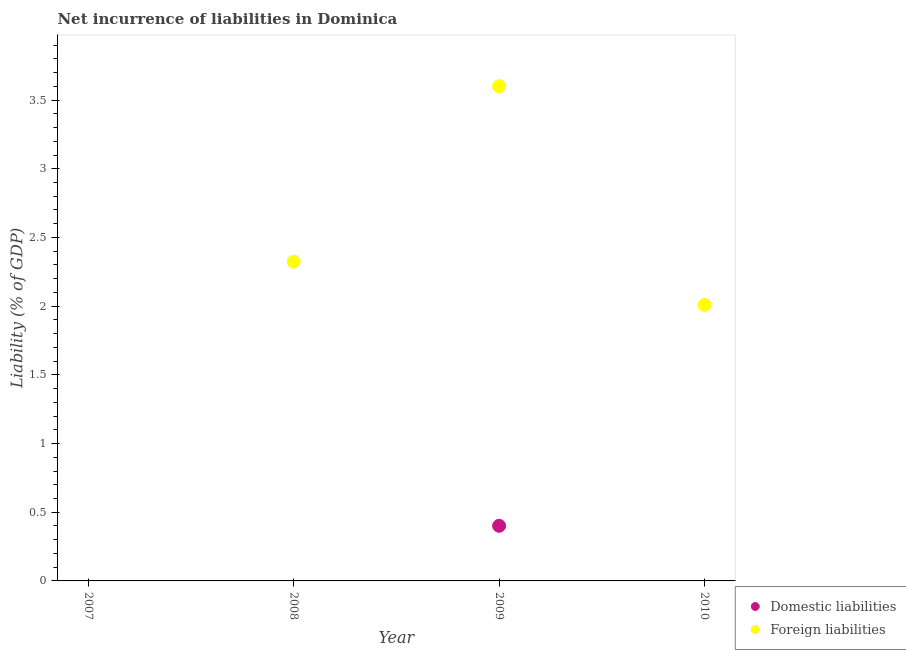How many different coloured dotlines are there?
Your response must be concise. 2. Is the number of dotlines equal to the number of legend labels?
Offer a very short reply. No. What is the incurrence of foreign liabilities in 2010?
Offer a very short reply. 2.01. Across all years, what is the maximum incurrence of foreign liabilities?
Keep it short and to the point. 3.6. Across all years, what is the minimum incurrence of domestic liabilities?
Keep it short and to the point. 0. What is the total incurrence of domestic liabilities in the graph?
Give a very brief answer. 0.4. What is the difference between the incurrence of foreign liabilities in 2008 and that in 2010?
Provide a succinct answer. 0.32. What is the difference between the incurrence of domestic liabilities in 2010 and the incurrence of foreign liabilities in 2008?
Offer a very short reply. -2.32. What is the average incurrence of foreign liabilities per year?
Your answer should be very brief. 1.98. In the year 2009, what is the difference between the incurrence of foreign liabilities and incurrence of domestic liabilities?
Your answer should be compact. 3.2. In how many years, is the incurrence of domestic liabilities greater than 3.1 %?
Offer a very short reply. 0. What is the ratio of the incurrence of foreign liabilities in 2008 to that in 2009?
Offer a very short reply. 0.65. What is the difference between the highest and the second highest incurrence of foreign liabilities?
Your response must be concise. 1.28. What is the difference between the highest and the lowest incurrence of domestic liabilities?
Give a very brief answer. 0.4. How many years are there in the graph?
Your answer should be very brief. 4. What is the difference between two consecutive major ticks on the Y-axis?
Your response must be concise. 0.5. Does the graph contain grids?
Keep it short and to the point. No. Where does the legend appear in the graph?
Make the answer very short. Bottom right. How many legend labels are there?
Provide a short and direct response. 2. What is the title of the graph?
Give a very brief answer. Net incurrence of liabilities in Dominica. Does "Urban" appear as one of the legend labels in the graph?
Ensure brevity in your answer.  No. What is the label or title of the Y-axis?
Make the answer very short. Liability (% of GDP). What is the Liability (% of GDP) in Foreign liabilities in 2008?
Make the answer very short. 2.32. What is the Liability (% of GDP) in Domestic liabilities in 2009?
Keep it short and to the point. 0.4. What is the Liability (% of GDP) in Foreign liabilities in 2009?
Your answer should be compact. 3.6. What is the Liability (% of GDP) of Domestic liabilities in 2010?
Make the answer very short. 0. What is the Liability (% of GDP) in Foreign liabilities in 2010?
Your answer should be very brief. 2.01. Across all years, what is the maximum Liability (% of GDP) of Domestic liabilities?
Keep it short and to the point. 0.4. Across all years, what is the maximum Liability (% of GDP) in Foreign liabilities?
Give a very brief answer. 3.6. What is the total Liability (% of GDP) in Domestic liabilities in the graph?
Provide a short and direct response. 0.4. What is the total Liability (% of GDP) of Foreign liabilities in the graph?
Your answer should be compact. 7.93. What is the difference between the Liability (% of GDP) of Foreign liabilities in 2008 and that in 2009?
Your answer should be very brief. -1.28. What is the difference between the Liability (% of GDP) of Foreign liabilities in 2008 and that in 2010?
Keep it short and to the point. 0.32. What is the difference between the Liability (% of GDP) in Foreign liabilities in 2009 and that in 2010?
Ensure brevity in your answer.  1.59. What is the difference between the Liability (% of GDP) in Domestic liabilities in 2009 and the Liability (% of GDP) in Foreign liabilities in 2010?
Ensure brevity in your answer.  -1.61. What is the average Liability (% of GDP) of Domestic liabilities per year?
Your answer should be very brief. 0.1. What is the average Liability (% of GDP) of Foreign liabilities per year?
Offer a terse response. 1.98. In the year 2009, what is the difference between the Liability (% of GDP) of Domestic liabilities and Liability (% of GDP) of Foreign liabilities?
Ensure brevity in your answer.  -3.2. What is the ratio of the Liability (% of GDP) in Foreign liabilities in 2008 to that in 2009?
Your answer should be very brief. 0.65. What is the ratio of the Liability (% of GDP) of Foreign liabilities in 2008 to that in 2010?
Provide a succinct answer. 1.16. What is the ratio of the Liability (% of GDP) of Foreign liabilities in 2009 to that in 2010?
Keep it short and to the point. 1.79. What is the difference between the highest and the second highest Liability (% of GDP) in Foreign liabilities?
Ensure brevity in your answer.  1.28. What is the difference between the highest and the lowest Liability (% of GDP) in Domestic liabilities?
Offer a terse response. 0.4. What is the difference between the highest and the lowest Liability (% of GDP) of Foreign liabilities?
Make the answer very short. 3.6. 